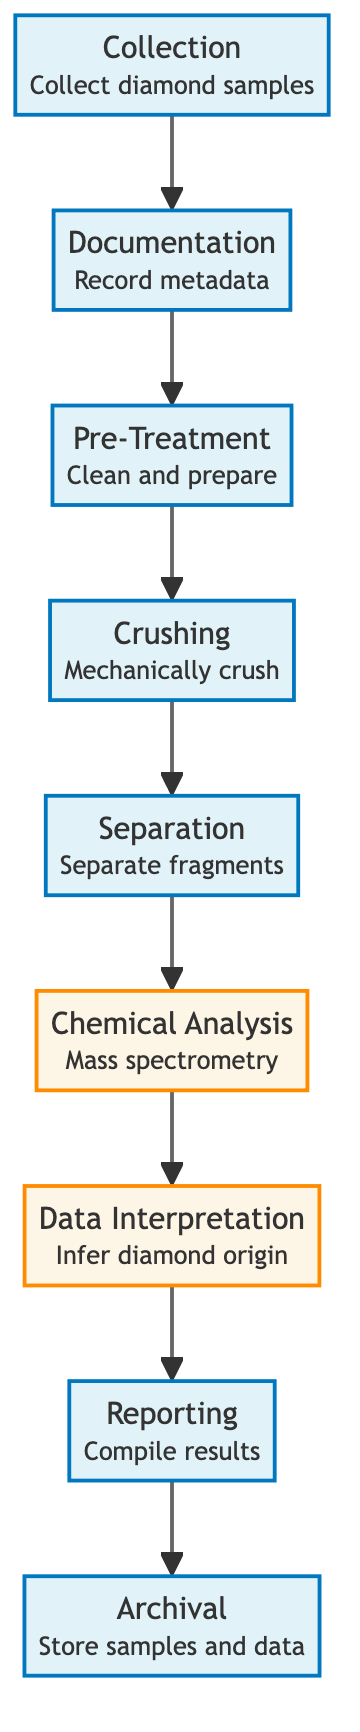What is the first step in the diamond analysis process? The first step is indicated by the node labeled "Collection", which states "Collect diamond samples". This node is the starting point of the flowchart.
Answer: Collection How many total steps are in the process flowchart? The diagram contains nine distinct nodes, each representing a step in the process, starting from Collection and ending with Archival.
Answer: Nine Which node follows the "Pre-Treatment" step? The flowchart shows that the step following "Pre-Treatment" is "Crushing". This is determined by moving forward from the "Pre-Treatment" node in the diagram.
Answer: Crushing What type of analysis is performed after the "Separation" step? After "Separation", the next step is "Chemical Analysis", which is specified in the diagram as involving "Mass spectrometry". Therefore, this type of analysis follows the separation process.
Answer: Mass spectrometry What is the last step in the diamond sample analysis process? The last step, as presented in the flowchart, is "Archival", which entails storing samples and data. This is the final node to complete the analysis process.
Answer: Archival Which two steps are classified as analysis in the diagram? The two steps classified as analysis are "Chemical Analysis" and "Data Interpretation". These nodes are explicitly marked with a different color scheme to denote analysis activities.
Answer: Chemical Analysis, Data Interpretation What happens immediately after "Data Interpretation"? After "Data Interpretation", the process moves to "Reporting", where results are compiled. This transition can be traced directly from the "Data Interpretation" node to the next node in the flowchart.
Answer: Reporting Which step involves cleaning and preparing the samples? The step involving cleaning and preparing the samples is "Pre-Treatment". This is explicitly noted in the diagram next to that node.
Answer: Pre-Treatment What is the purpose of the "Documentation" step in the process? The "Documentation" step serves the purpose of recording metadata related to the diamond samples, ensuring that all relevant information is captured at the outset of the analysis process.
Answer: Record metadata 